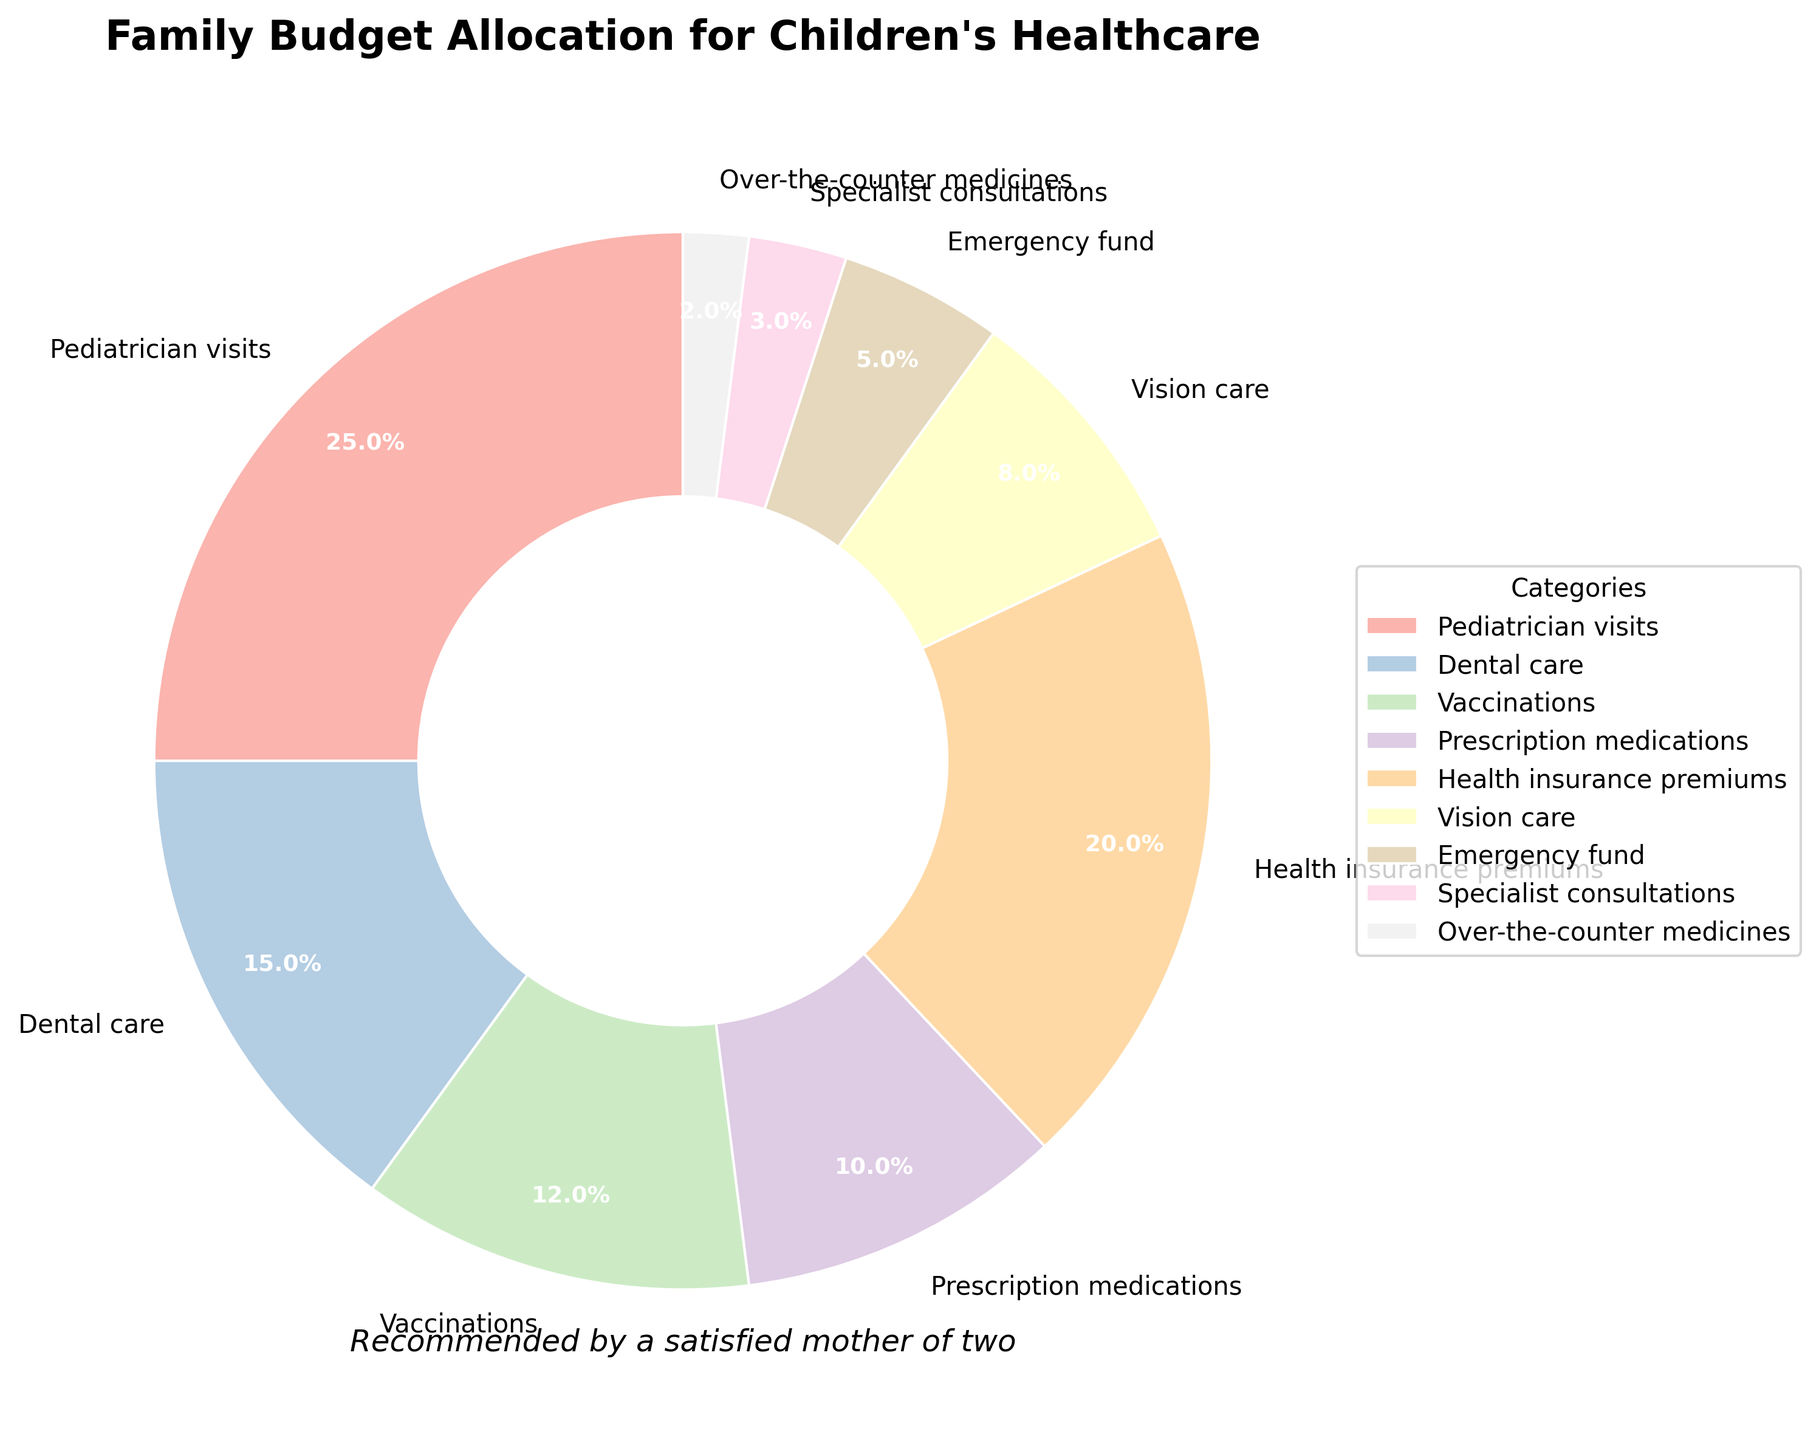what is the total percentage allocated to dental care and vision care? To find the total percentage allocated to both dental care and vision care, add the individual percentages given: Dental care (15%) and Vision care (8%), so 15% + 8% = 23%
Answer: 23% Which category has the highest allocation? Referring to the pie chart, we can see that Pediatrician visits has the largest portion, occupying 25% of the overall chart.
Answer: Pediatrician visits How much more is allocated to health insurance premiums compared to over-the-counter medicines? Health insurance premiums are allocated 20% and over-the-counter medicines are allocated 2%. The difference is 20% - 2% = 18%
Answer: 18% Name two categories with the smallest allocations. Referring to the pie chart, the two categories with the smallest allocations are Specialist consultations (3%) and Over-the-counter medicines (2%).
Answer: Specialist consultations, Over-the-counter medicines What is the combined percentage allocated to pediatrician visits, dental care, and vaccinations? The combined percentage is calculated by adding: Pediatrician visits (25%), Dental care (15%), and Vaccinations (12%), so 25% + 15% + 12% = 52%
Answer: 52% Does vision care get more allocation than emergency fund? Referring to the pie chart, Vision care gets 8% while emergency fund gets 5%, so yes, Vision care gets more allocation than emergency fund.
Answer: Yes Which category gets exactly 10% allocation? By observing the pie chart, Prescription medications are allocated exactly 10%.
Answer: Prescription medications Among pediatrician visits, dental care, and vaccinations, which has the highest allocation? Comparing Pediatrician visits (25%), Dental care (15%), and Vaccinations (12%), Pediatrician visits has the highest allocation.
Answer: Pediatrician visits How much is allocated to specialist consultations and over-the-counter medicines combined? Adding the allocations for Specialist consultations (3%) and Over-the-counter medicines (2%) gives 3% + 2% = 5%
Answer: 5% Which color is used for health insurance premiums, and how can you identify it? By referring to the legend and visual information, health insurance premiums are shown in a specific segment. The exact color code isn't provided here, but it typically matches the segment labeled "Health insurance premiums".
Answer: Identifiable by checking the labeled segment 